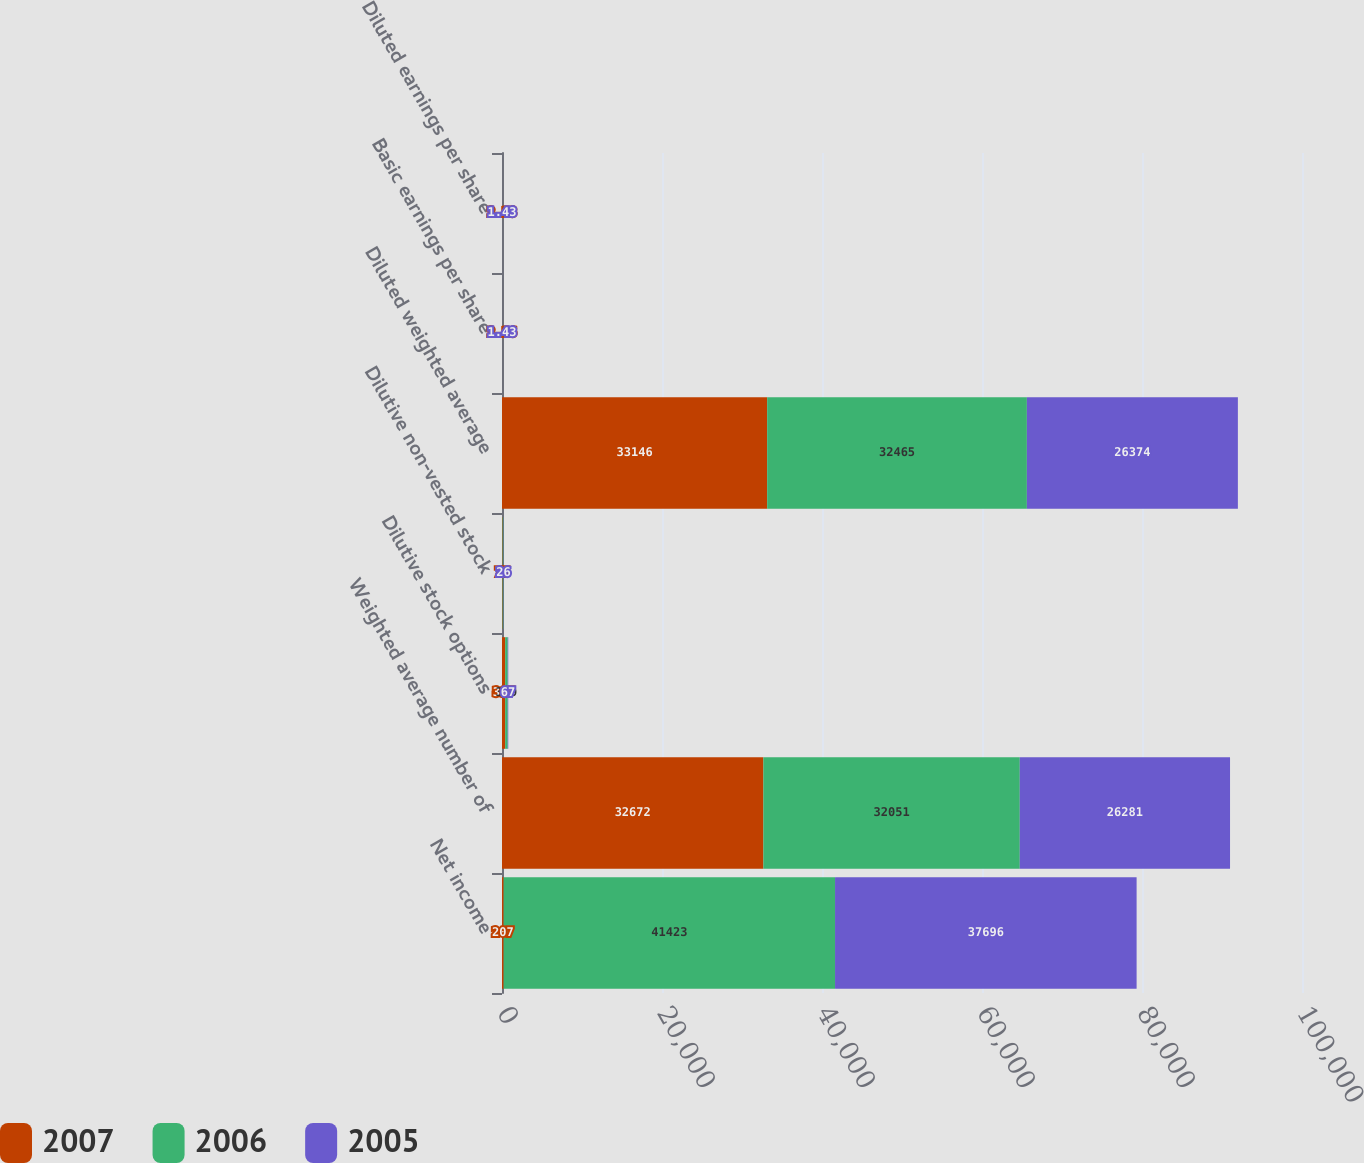Convert chart. <chart><loc_0><loc_0><loc_500><loc_500><stacked_bar_chart><ecel><fcel>Net income<fcel>Weighted average number of<fcel>Dilutive stock options<fcel>Dilutive non-vested stock<fcel>Diluted weighted average<fcel>Basic earnings per share<fcel>Diluted earnings per share<nl><fcel>2007<fcel>207<fcel>32672<fcel>397<fcel>77<fcel>33146<fcel>2.16<fcel>2.13<nl><fcel>2006<fcel>41423<fcel>32051<fcel>319<fcel>95<fcel>32465<fcel>1.29<fcel>1.28<nl><fcel>2005<fcel>37696<fcel>26281<fcel>67<fcel>26<fcel>26374<fcel>1.43<fcel>1.43<nl></chart> 